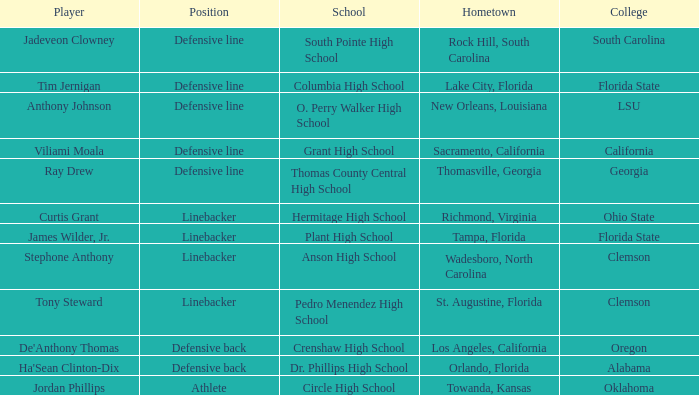Parse the table in full. {'header': ['Player', 'Position', 'School', 'Hometown', 'College'], 'rows': [['Jadeveon Clowney', 'Defensive line', 'South Pointe High School', 'Rock Hill, South Carolina', 'South Carolina'], ['Tim Jernigan', 'Defensive line', 'Columbia High School', 'Lake City, Florida', 'Florida State'], ['Anthony Johnson', 'Defensive line', 'O. Perry Walker High School', 'New Orleans, Louisiana', 'LSU'], ['Viliami Moala', 'Defensive line', 'Grant High School', 'Sacramento, California', 'California'], ['Ray Drew', 'Defensive line', 'Thomas County Central High School', 'Thomasville, Georgia', 'Georgia'], ['Curtis Grant', 'Linebacker', 'Hermitage High School', 'Richmond, Virginia', 'Ohio State'], ['James Wilder, Jr.', 'Linebacker', 'Plant High School', 'Tampa, Florida', 'Florida State'], ['Stephone Anthony', 'Linebacker', 'Anson High School', 'Wadesboro, North Carolina', 'Clemson'], ['Tony Steward', 'Linebacker', 'Pedro Menendez High School', 'St. Augustine, Florida', 'Clemson'], ["De'Anthony Thomas", 'Defensive back', 'Crenshaw High School', 'Los Angeles, California', 'Oregon'], ["Ha'Sean Clinton-Dix", 'Defensive back', 'Dr. Phillips High School', 'Orlando, Florida', 'Alabama'], ['Jordan Phillips', 'Athlete', 'Circle High School', 'Towanda, Kansas', 'Oklahoma']]} What position is for Dr. Phillips high school? Defensive back. 